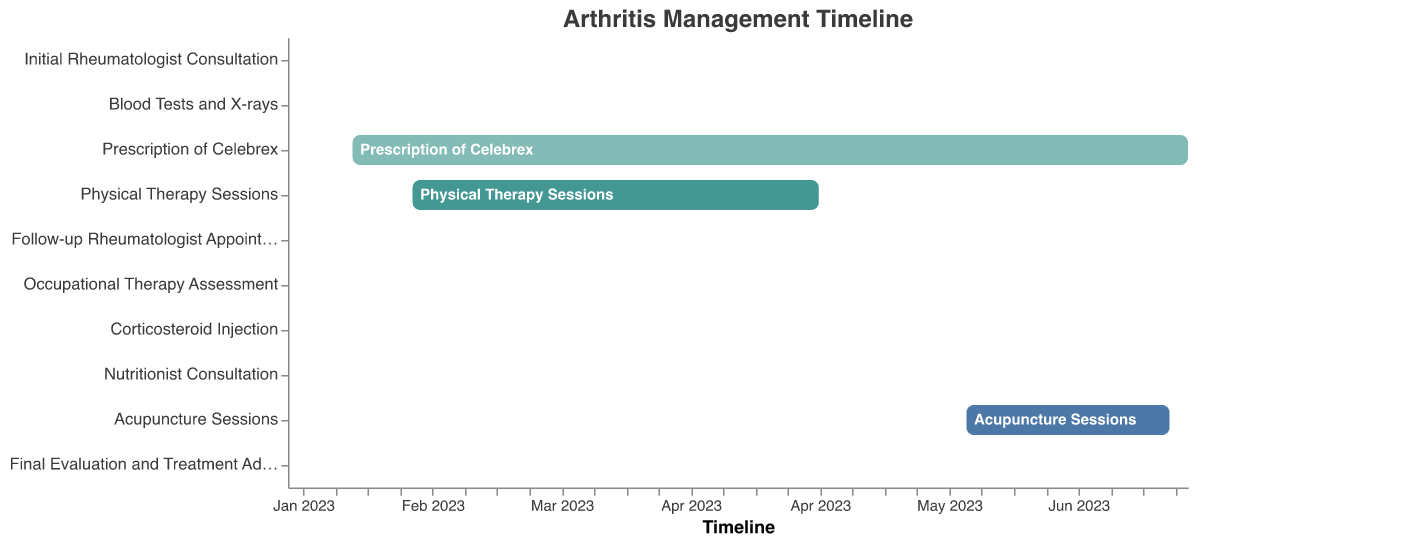How long was the prescription of Celebrex scheduled for? The Celebrex was prescribed from January 19 to July 19, 2023. The difference between these two dates is exactly 6 months.
Answer: 6 months What is the beginning date of the Blood Tests and X-rays task? The Gantt Chart indicates that the Blood Tests and X-rays task started on January 12, 2023.
Answer: January 12, 2023 How many sessions or appointments were scheduled in March 2023? The only task shown in March 2023 is the Follow-up Rheumatologist Appointment on March 15, 2023, so there is one session.
Answer: 1 Which task has the longest duration? By examining the bars in the Gantt Chart, the Prescription of Celebrex task, running from January 19 to July 19, 2023, appears to be the longest.
Answer: Prescription of Celebrex Were there any appointments or treatments in July 2023? Yes, the chart shows Acupuncture Sessions ending on July 15, and the Final Evaluation and Treatment Adjustment scheduled on July 1.
Answer: Yes Which had a longer duration, Physical Therapy Sessions or Acupuncture Sessions? Physical Therapy Sessions lasted from February 1 to April 30, 2023, which is 3 months, while Acupuncture Sessions lasted from June 1 to July 15, 2023, which is 1.5 months. Therefore, Physical Therapy Sessions lasted longer.
Answer: Physical Therapy Sessions How many different types of tasks are displayed in the Gantt Chart? By counting the different tasks listed on the vertical axis of the chart, there are 10 different tasks shown.
Answer: 10 Was there a follow-up appointment after the initial Rheumatologist consultation? If so, when was it? Yes, the follow-up appointment is shown on March 15, 2023, as indicated by the respective task in the chart.
Answer: March 15, 2023 When did the Corticosteroid Injection take place in relation to the Nutritionist Consultation? According to the Gantt Chart, the Corticosteroid Injection took place on May 2, 2023, while the Nutritionist Consultation happened later on May 20, 2023.
Answer: Earlier How many tasks span more than a month? By examining the date ranges, the tasks that span more than a month are: Prescription of Celebrex (6 months), Physical Therapy Sessions (3 months), and Acupuncture Sessions (1.5 months). There are a total of 3 such tasks.
Answer: 3 